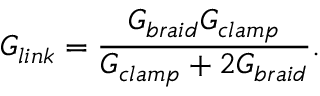<formula> <loc_0><loc_0><loc_500><loc_500>G _ { l i n k } = \frac { G _ { b r a i d } G _ { c l a m p } } { G _ { c l a m p } + 2 G _ { b r a i d } } .</formula> 